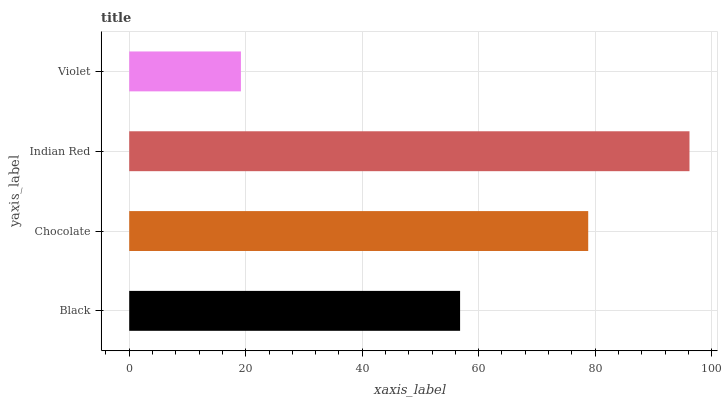Is Violet the minimum?
Answer yes or no. Yes. Is Indian Red the maximum?
Answer yes or no. Yes. Is Chocolate the minimum?
Answer yes or no. No. Is Chocolate the maximum?
Answer yes or no. No. Is Chocolate greater than Black?
Answer yes or no. Yes. Is Black less than Chocolate?
Answer yes or no. Yes. Is Black greater than Chocolate?
Answer yes or no. No. Is Chocolate less than Black?
Answer yes or no. No. Is Chocolate the high median?
Answer yes or no. Yes. Is Black the low median?
Answer yes or no. Yes. Is Violet the high median?
Answer yes or no. No. Is Indian Red the low median?
Answer yes or no. No. 